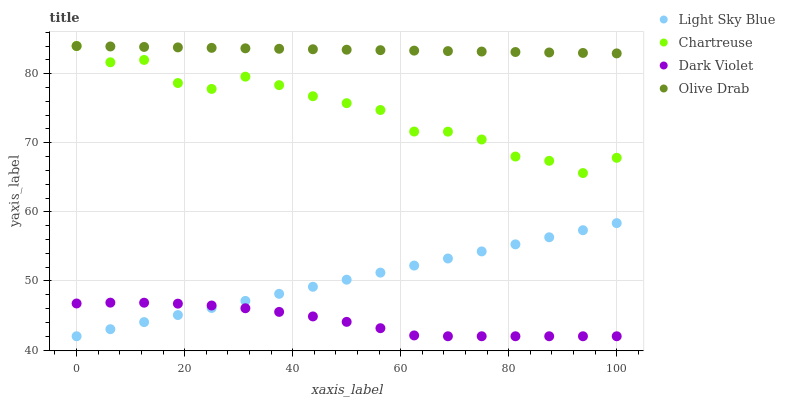Does Dark Violet have the minimum area under the curve?
Answer yes or no. Yes. Does Olive Drab have the maximum area under the curve?
Answer yes or no. Yes. Does Light Sky Blue have the minimum area under the curve?
Answer yes or no. No. Does Light Sky Blue have the maximum area under the curve?
Answer yes or no. No. Is Light Sky Blue the smoothest?
Answer yes or no. Yes. Is Chartreuse the roughest?
Answer yes or no. Yes. Is Olive Drab the smoothest?
Answer yes or no. No. Is Olive Drab the roughest?
Answer yes or no. No. Does Light Sky Blue have the lowest value?
Answer yes or no. Yes. Does Olive Drab have the lowest value?
Answer yes or no. No. Does Olive Drab have the highest value?
Answer yes or no. Yes. Does Light Sky Blue have the highest value?
Answer yes or no. No. Is Light Sky Blue less than Chartreuse?
Answer yes or no. Yes. Is Chartreuse greater than Dark Violet?
Answer yes or no. Yes. Does Olive Drab intersect Chartreuse?
Answer yes or no. Yes. Is Olive Drab less than Chartreuse?
Answer yes or no. No. Is Olive Drab greater than Chartreuse?
Answer yes or no. No. Does Light Sky Blue intersect Chartreuse?
Answer yes or no. No. 